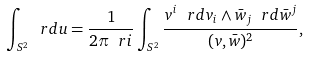Convert formula to latex. <formula><loc_0><loc_0><loc_500><loc_500>\int _ { S ^ { 2 } } \ r d u = \frac { 1 } { 2 \pi \ r i } \int _ { S ^ { 2 } } \frac { v ^ { i } \ r d v _ { i } \wedge \bar { w } _ { j } \ r d \bar { w } ^ { j } } { ( v , \bar { w } ) ^ { 2 } } ,</formula> 